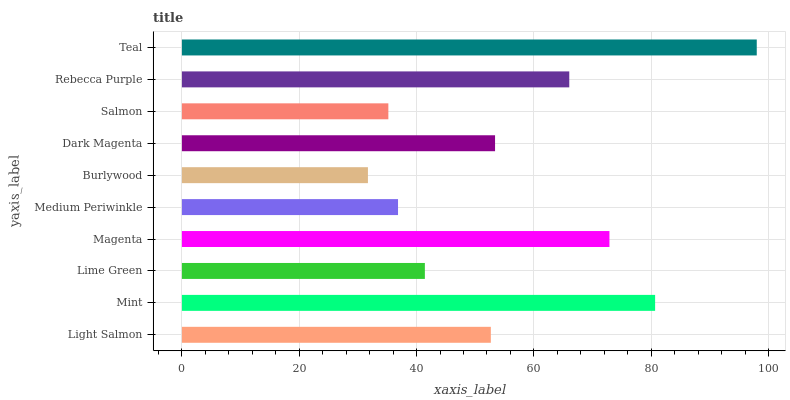Is Burlywood the minimum?
Answer yes or no. Yes. Is Teal the maximum?
Answer yes or no. Yes. Is Mint the minimum?
Answer yes or no. No. Is Mint the maximum?
Answer yes or no. No. Is Mint greater than Light Salmon?
Answer yes or no. Yes. Is Light Salmon less than Mint?
Answer yes or no. Yes. Is Light Salmon greater than Mint?
Answer yes or no. No. Is Mint less than Light Salmon?
Answer yes or no. No. Is Dark Magenta the high median?
Answer yes or no. Yes. Is Light Salmon the low median?
Answer yes or no. Yes. Is Magenta the high median?
Answer yes or no. No. Is Burlywood the low median?
Answer yes or no. No. 